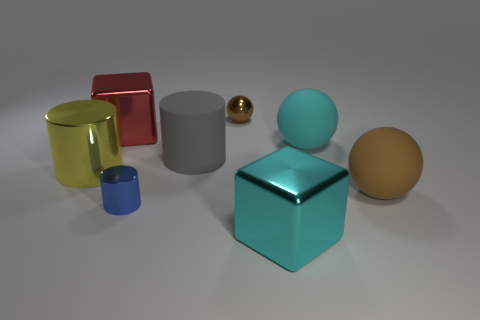Can you tell me the colors of the objects and provide a detail about the lighting in the scene? Sure, the objects have varying colors: one cylinder is transparent yellow, another larger one is gray, the smaller cube is blue, and the larger cube is teal. The sphere is brown, and there is also a small golden ball. The lighting in the scene is soft and diffused, casting gentle shadows to the right of the objects, suggesting a light source from the left. 